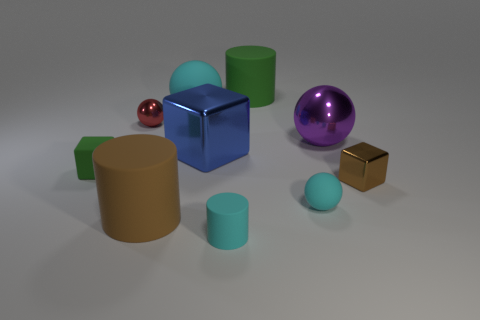What color is the other block that is the same size as the brown cube?
Your response must be concise. Green. There is a small green matte object; is its shape the same as the green rubber object behind the tiny green matte thing?
Your response must be concise. No. The big thing that is the same color as the tiny rubber ball is what shape?
Your answer should be compact. Sphere. How many cyan rubber cylinders are in front of the small sphere that is behind the metal ball that is right of the small cyan rubber cylinder?
Keep it short and to the point. 1. There is a cyan matte thing that is in front of the cyan ball in front of the brown metal block; what is its size?
Offer a terse response. Small. There is a cube that is made of the same material as the large cyan object; what size is it?
Provide a short and direct response. Small. What shape is the object that is left of the cyan cylinder and in front of the matte block?
Offer a very short reply. Cylinder. Is the number of large shiny objects that are to the left of the big purple metal thing the same as the number of large cyan spheres?
Your response must be concise. Yes. What number of objects are either tiny cylinders or large rubber things that are behind the large purple sphere?
Ensure brevity in your answer.  3. Are there any other large blue metal objects of the same shape as the blue object?
Your answer should be very brief. No. 